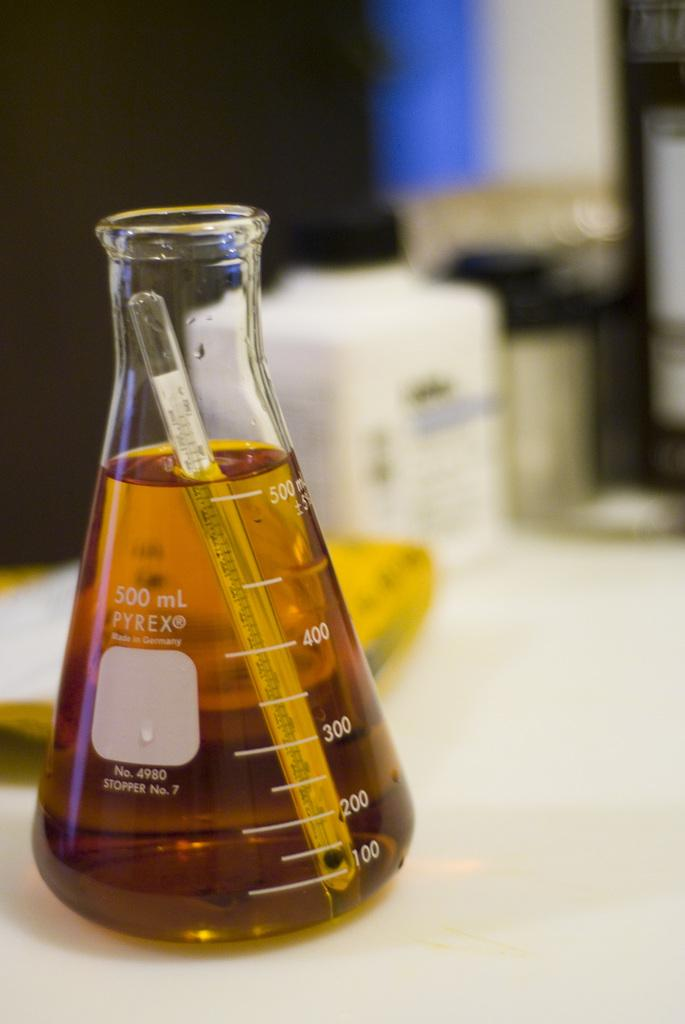<image>
Provide a brief description of the given image. Beaker that shows 500 mL by Pyrex on a table. 